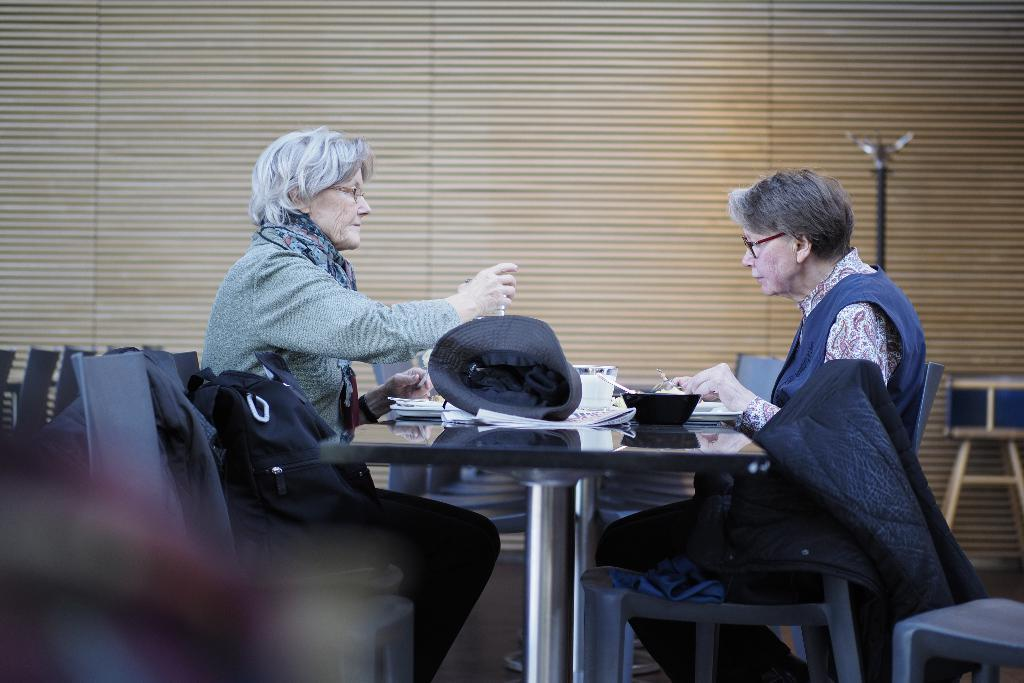How many chairs are visible in the image? There are two chairs in the image. What are the chairs being used for? People are sitting on the chairs. What is on the table in the image? There is a cap, papers, and a bowl on the table. Are there any bags visible in the image? Yes, there are bags in the image. What type of agreement was reached in the cave depicted in the image? There is no cave or agreement present in the image; it features chairs, people, a table, and various objects on the table. 